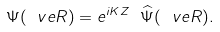Convert formula to latex. <formula><loc_0><loc_0><loc_500><loc_500>\Psi ( \ v e { R } ) = e ^ { i K Z } \ \widehat { \Psi } ( \ v e { R } ) .</formula> 